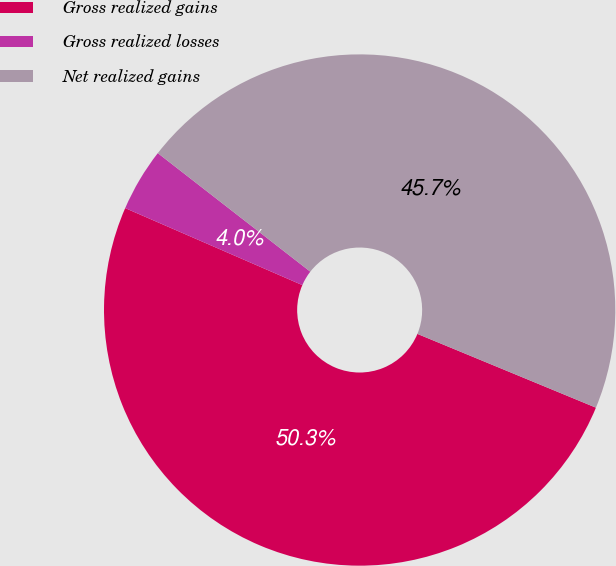Convert chart. <chart><loc_0><loc_0><loc_500><loc_500><pie_chart><fcel>Gross realized gains<fcel>Gross realized losses<fcel>Net realized gains<nl><fcel>50.29%<fcel>3.99%<fcel>45.72%<nl></chart> 